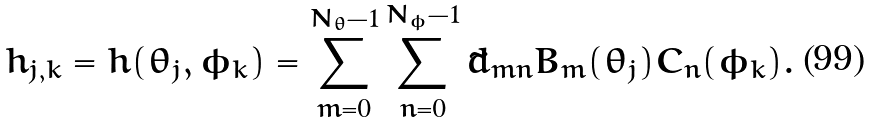Convert formula to latex. <formula><loc_0><loc_0><loc_500><loc_500>h _ { j , k } = h ( \theta _ { j } , \phi _ { k } ) = \sum _ { m = 0 } ^ { N _ { \theta } - 1 } \sum _ { n = 0 } ^ { N _ { \phi } - 1 } \tilde { d } _ { m n } B _ { m } ( \theta _ { j } ) C _ { n } ( \phi _ { k } ) .</formula> 